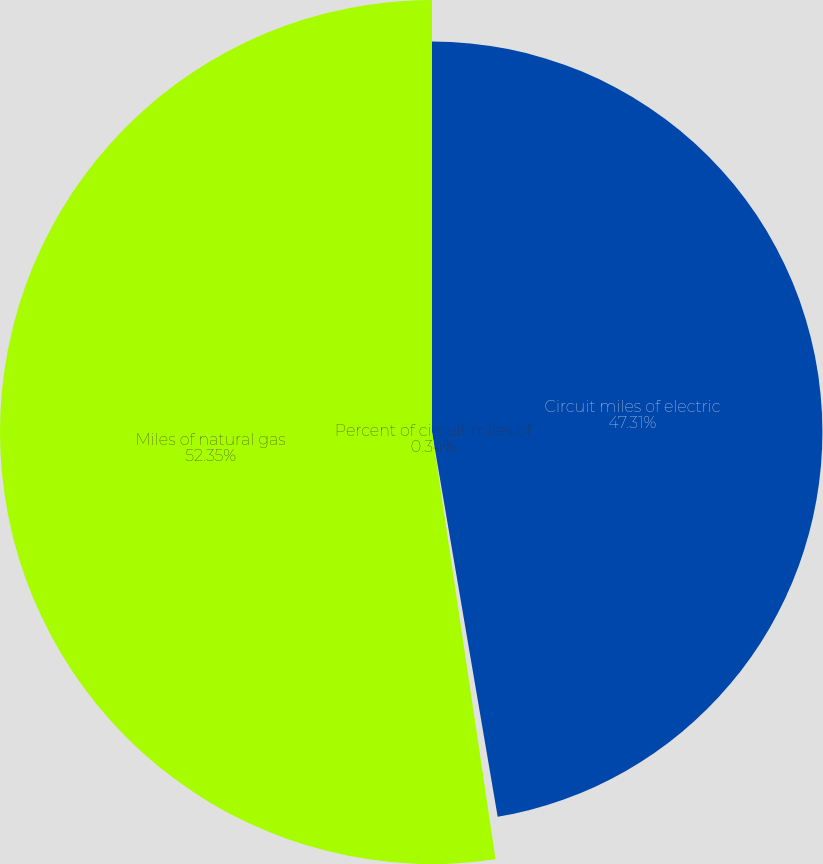Convert chart. <chart><loc_0><loc_0><loc_500><loc_500><pie_chart><fcel>Circuit miles of electric<fcel>Percent of circuit miles of<fcel>Miles of natural gas<nl><fcel>47.31%<fcel>0.34%<fcel>52.35%<nl></chart> 